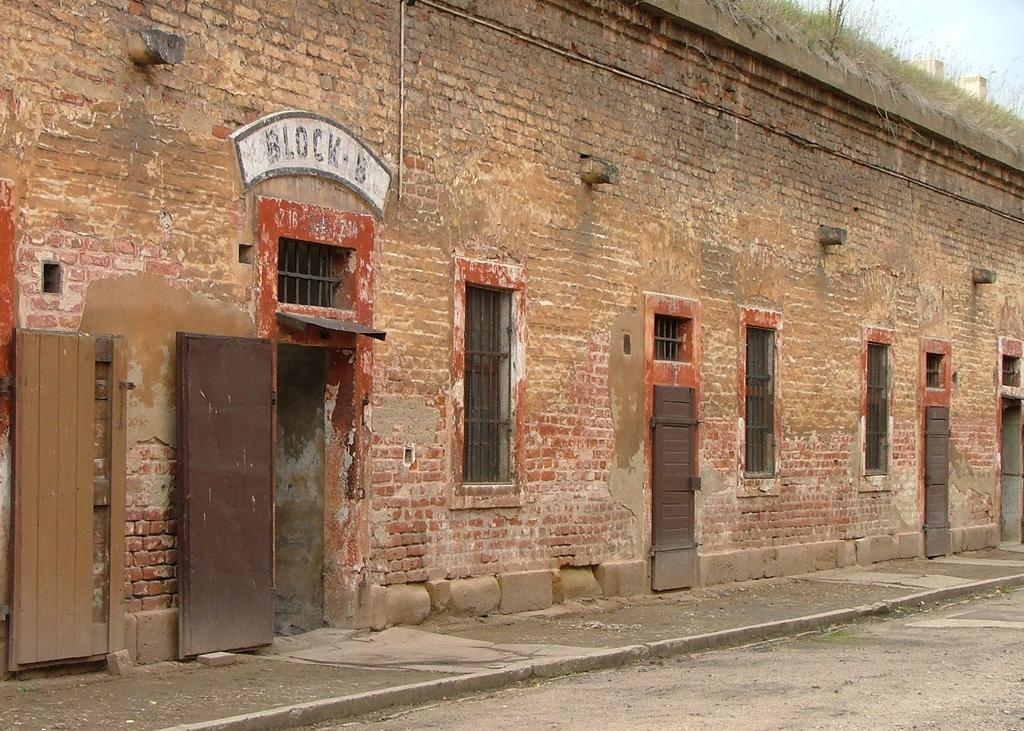Could you give a brief overview of what you see in this image? In this image I can see the building which is in brown color. There are the windows to it. In the back I can see the grass on the building and the sky. 